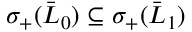Convert formula to latex. <formula><loc_0><loc_0><loc_500><loc_500>\sigma _ { + } ( \bar { L } _ { 0 } ) \subseteq \sigma _ { + } ( \bar { L } _ { 1 } )</formula> 